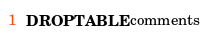<code> <loc_0><loc_0><loc_500><loc_500><_SQL_>DROP TABLE comments
</code> 